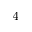Convert formula to latex. <formula><loc_0><loc_0><loc_500><loc_500>^ { 4 }</formula> 